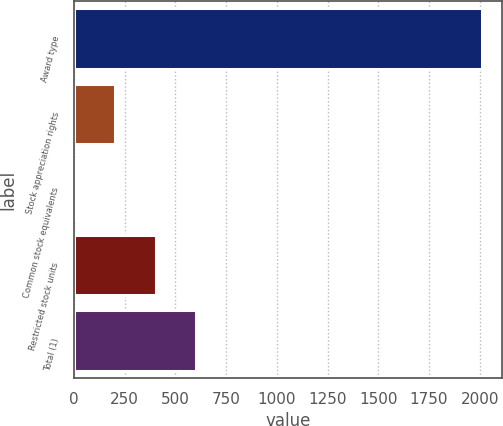Convert chart. <chart><loc_0><loc_0><loc_500><loc_500><bar_chart><fcel>Award type<fcel>Stock appreciation rights<fcel>Common stock equivalents<fcel>Restricted stock units<fcel>Total (1)<nl><fcel>2011<fcel>201.55<fcel>0.5<fcel>402.6<fcel>603.65<nl></chart> 